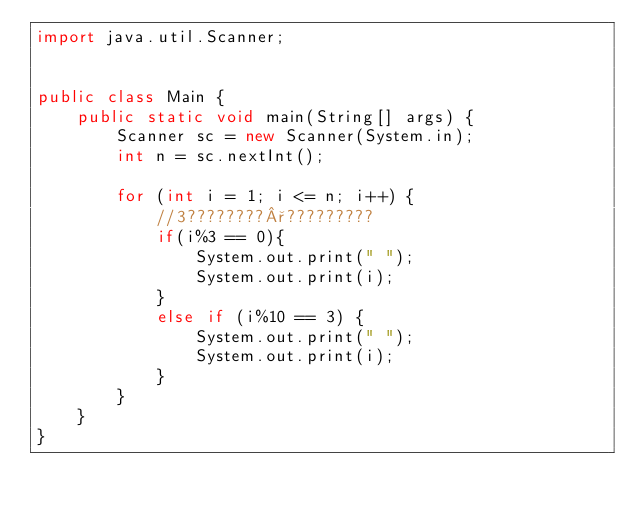<code> <loc_0><loc_0><loc_500><loc_500><_Java_>import java.util.Scanner;


public class Main {
	public static void main(String[] args) {
		Scanner sc = new Scanner(System.in);
		int n = sc.nextInt();
		
		for (int i = 1; i <= n; i++) {
			//3????????°?????????
			if(i%3 == 0){
				System.out.print(" ");
				System.out.print(i);
			}
			else if (i%10 == 3) {
				System.out.print(" ");
				System.out.print(i);
			}
		}
	}
}</code> 